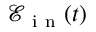<formula> <loc_0><loc_0><loc_500><loc_500>\mathcal { E } _ { i n } ( t )</formula> 